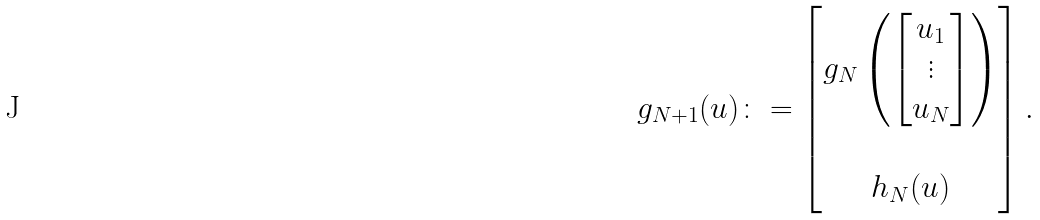<formula> <loc_0><loc_0><loc_500><loc_500>g _ { N + 1 } ( u ) \colon = \begin{bmatrix} g _ { N } \left ( \begin{bmatrix} u _ { 1 } \\ \vdots \\ u _ { N } \end{bmatrix} \right ) \\ \\ h _ { N } ( u ) \end{bmatrix} .</formula> 